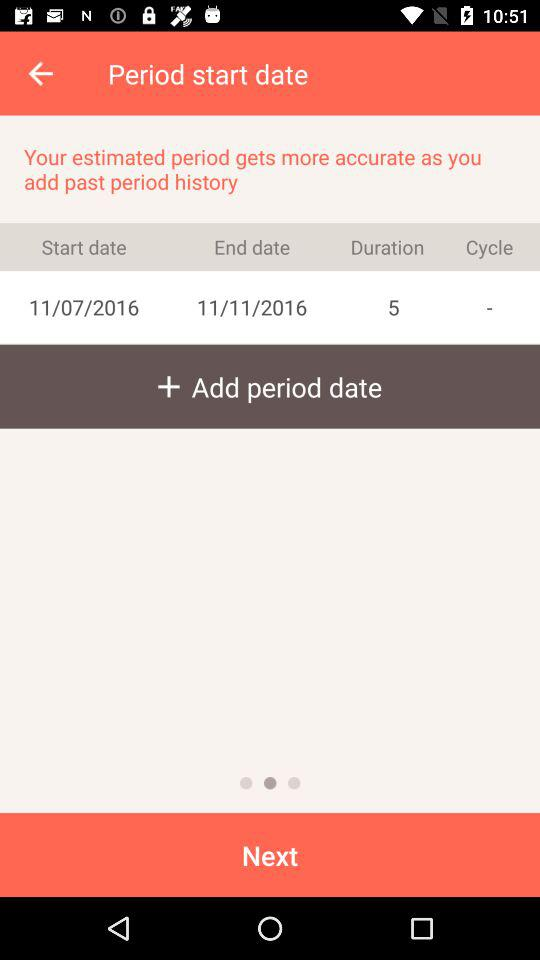What is the duration? The duration is 5 days. 